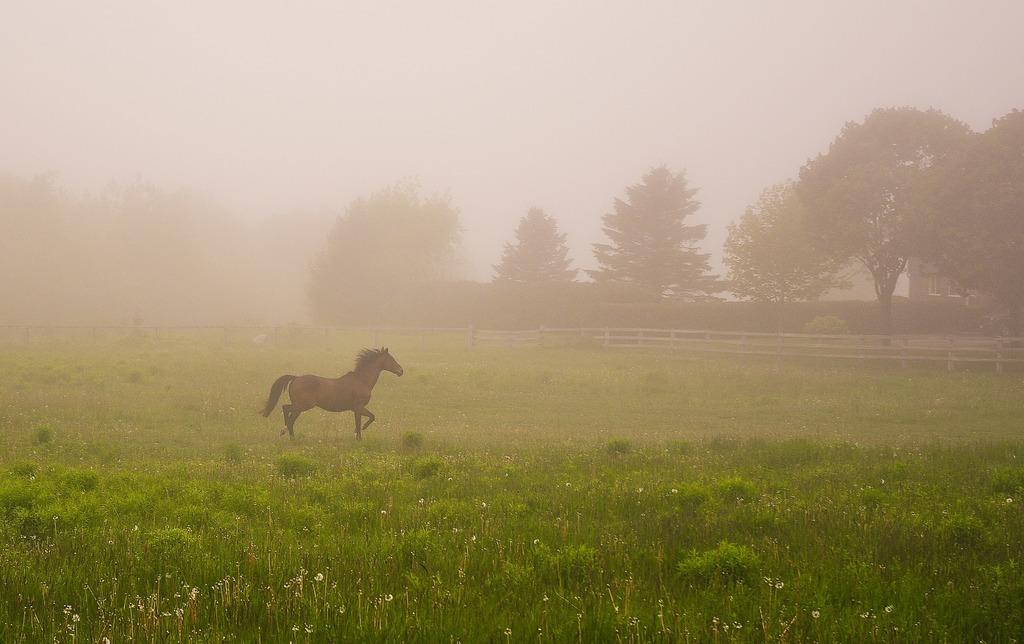What animal is present in the image? There is a horse in the image. What type of vegetation can be seen in the image? There is grass in the image. What structure is present in the image? There is a fence in the image. What type of natural feature is visible in the image? There are trees on the ground in the image. What type of man-made structure is visible in the image? There is a building on the right side of the image. What part of the natural environment is visible in the image? The sky is visible in the image. What type of health supplement is the horse taking in the image? There is no indication in the image that the horse is taking any health supplements. Can you see a cub playing with the horse in the image? There is no cub present in the image, and the horse is not interacting with any other animals. 